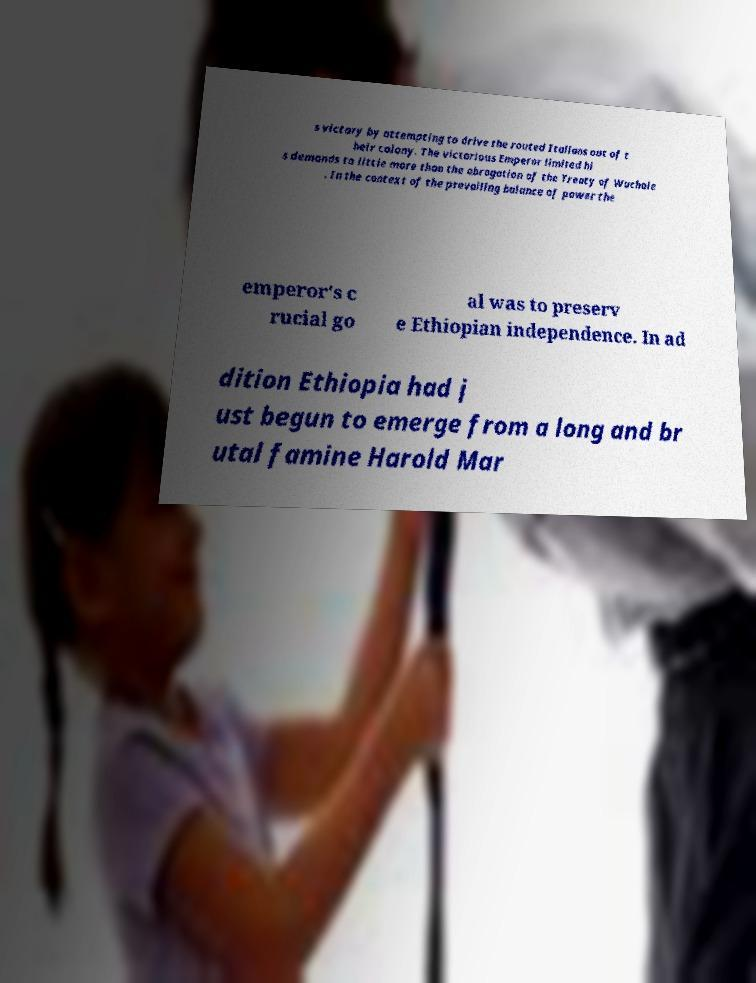What messages or text are displayed in this image? I need them in a readable, typed format. s victory by attempting to drive the routed Italians out of t heir colony. The victorious Emperor limited hi s demands to little more than the abrogation of the Treaty of Wuchale . In the context of the prevailing balance of power the emperor's c rucial go al was to preserv e Ethiopian independence. In ad dition Ethiopia had j ust begun to emerge from a long and br utal famine Harold Mar 